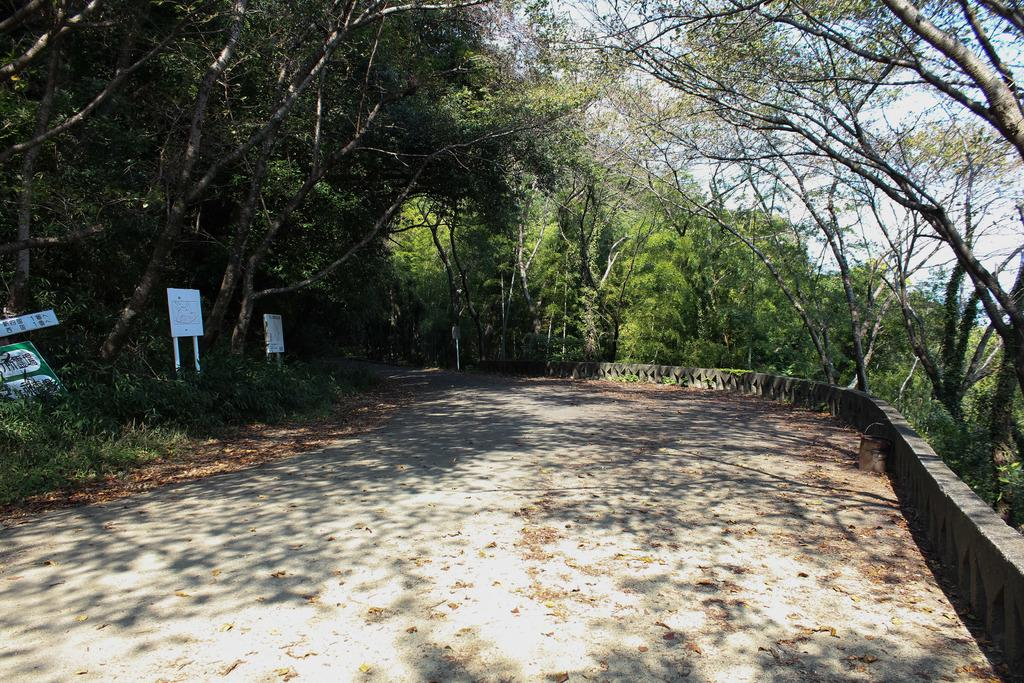What is located on the left side of the image? There are boards and trees on the left side of the image. What type of vegetation is present on both sides of the image? There are trees on both the left and right sides of the image. What is visible at the top of the image? The sky is visible at the top of the image. Where is the flame located in the image? There is no flame present in the image. What type of playground equipment can be seen in the image? There is no playground equipment present in the image. 